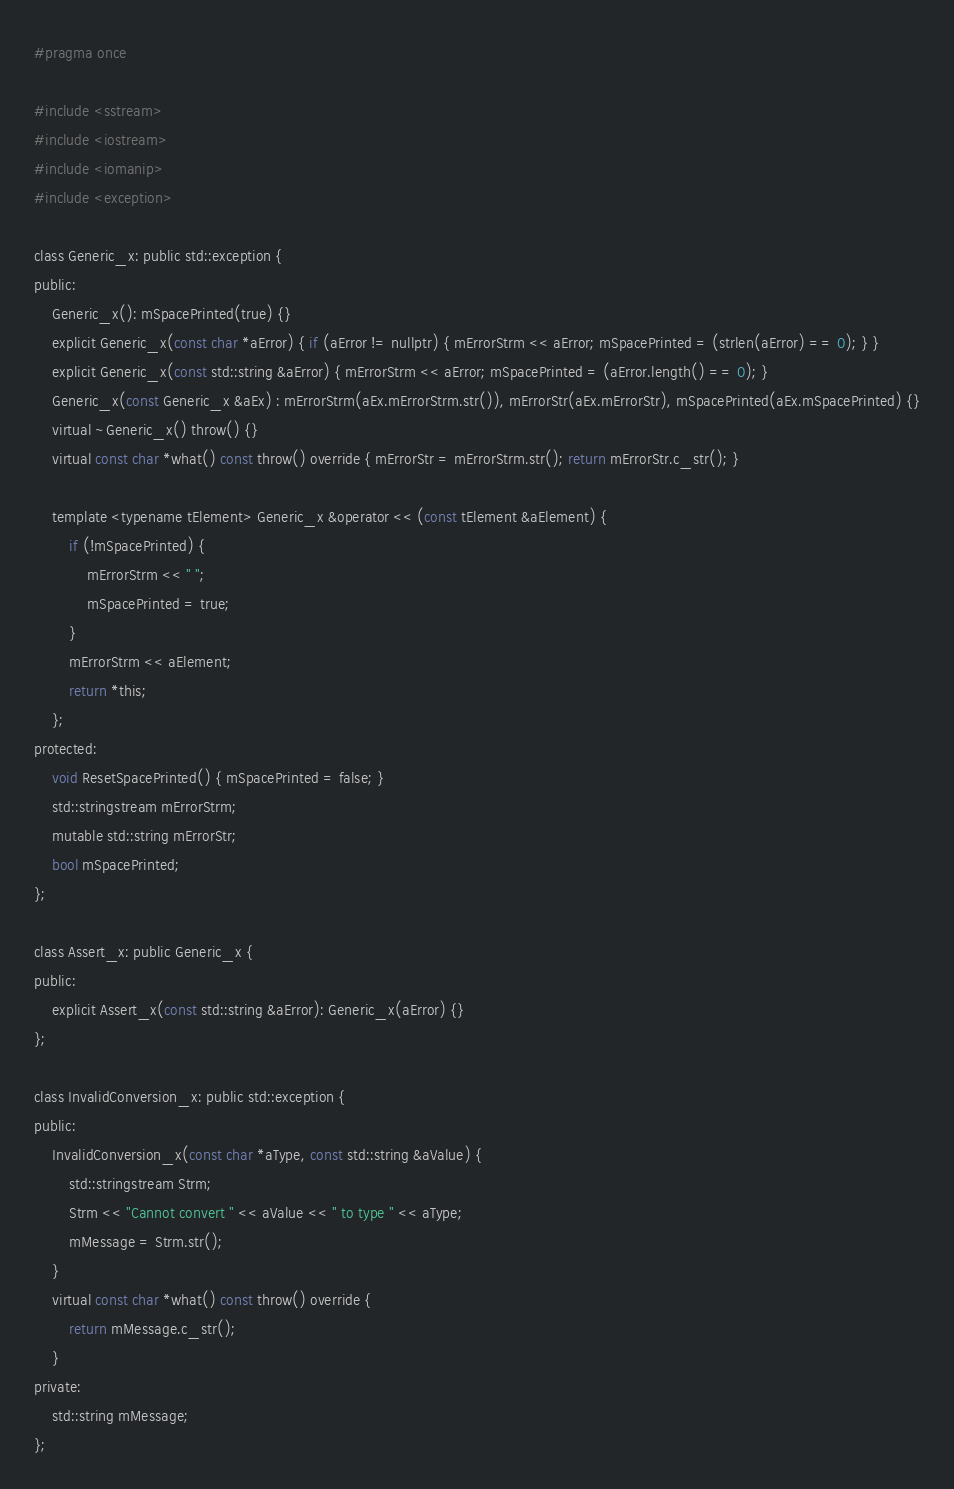<code> <loc_0><loc_0><loc_500><loc_500><_C_>#pragma once

#include <sstream>
#include <iostream>
#include <iomanip>
#include <exception>

class Generic_x: public std::exception {
public:
	Generic_x(): mSpacePrinted(true) {}
	explicit Generic_x(const char *aError) { if (aError != nullptr) { mErrorStrm << aError; mSpacePrinted = (strlen(aError) == 0); } }
	explicit Generic_x(const std::string &aError) { mErrorStrm << aError; mSpacePrinted = (aError.length() == 0); }
	Generic_x(const Generic_x &aEx) : mErrorStrm(aEx.mErrorStrm.str()), mErrorStr(aEx.mErrorStr), mSpacePrinted(aEx.mSpacePrinted) {}
	virtual ~Generic_x() throw() {}
	virtual const char *what() const throw() override { mErrorStr = mErrorStrm.str(); return mErrorStr.c_str(); }

	template <typename tElement> Generic_x &operator << (const tElement &aElement) {
		if (!mSpacePrinted) {
			mErrorStrm << " ";
			mSpacePrinted = true;
		}
		mErrorStrm << aElement;
		return *this;
	};
protected:
	void ResetSpacePrinted() { mSpacePrinted = false; }
	std::stringstream mErrorStrm;
	mutable std::string mErrorStr;
	bool mSpacePrinted;
};

class Assert_x: public Generic_x {
public:
	explicit Assert_x(const std::string &aError): Generic_x(aError) {}
};

class InvalidConversion_x: public std::exception {
public:
	InvalidConversion_x(const char *aType, const std::string &aValue) {
		std::stringstream Strm;
		Strm << "Cannot convert " << aValue << " to type " << aType;
		mMessage = Strm.str();
	}
	virtual const char *what() const throw() override {
		return mMessage.c_str();
	}
private:
	std::string mMessage;
};

</code> 